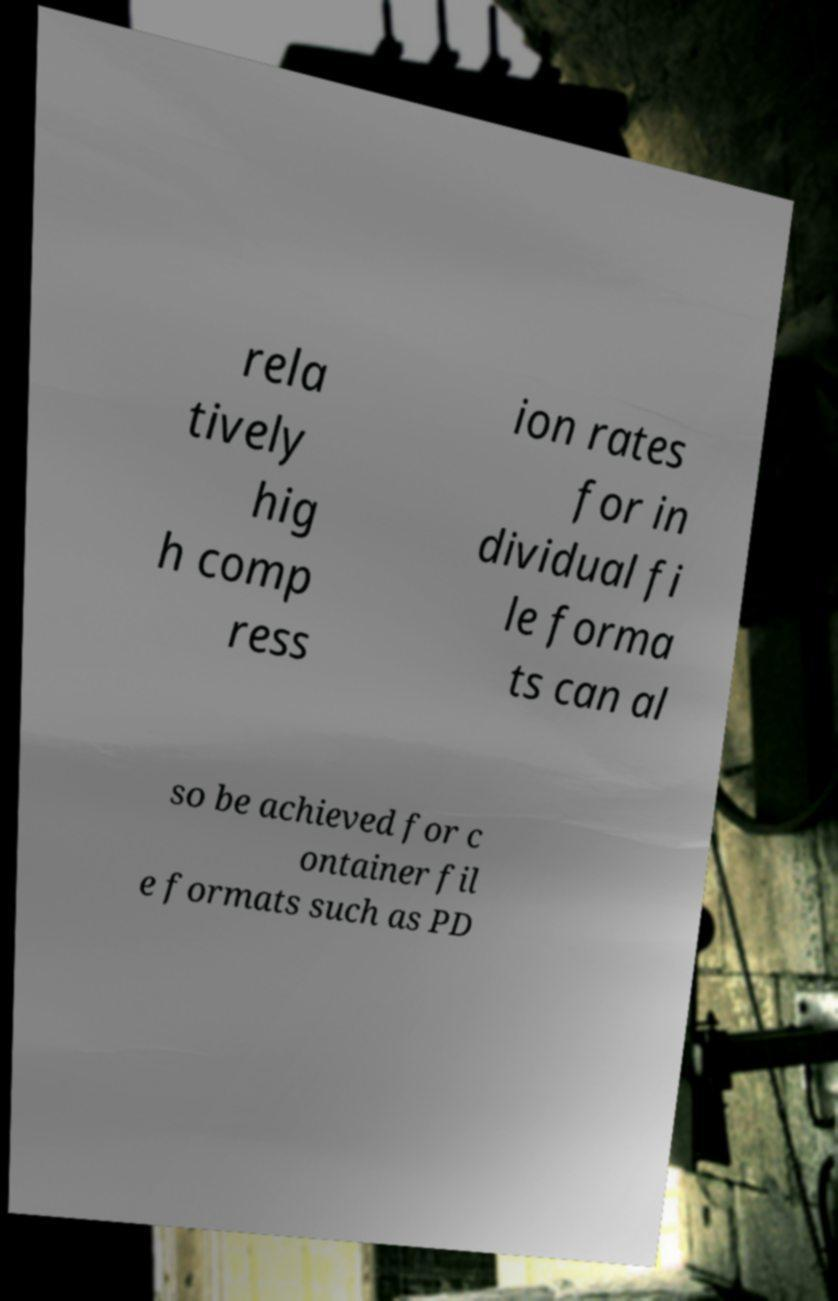Please identify and transcribe the text found in this image. rela tively hig h comp ress ion rates for in dividual fi le forma ts can al so be achieved for c ontainer fil e formats such as PD 